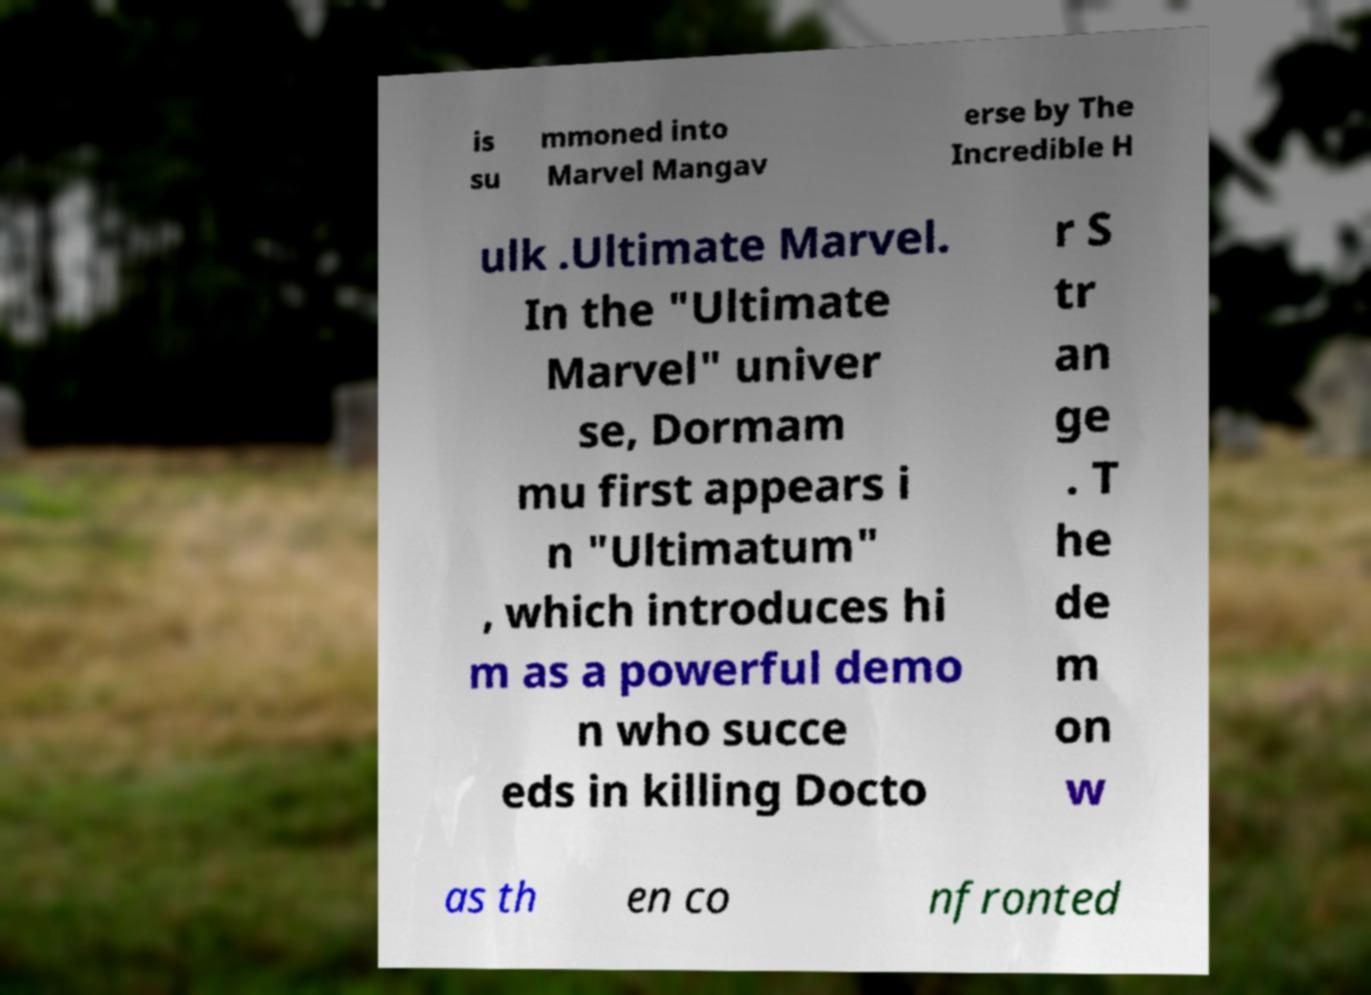Please read and relay the text visible in this image. What does it say? is su mmoned into Marvel Mangav erse by The Incredible H ulk .Ultimate Marvel. In the "Ultimate Marvel" univer se, Dormam mu first appears i n "Ultimatum" , which introduces hi m as a powerful demo n who succe eds in killing Docto r S tr an ge . T he de m on w as th en co nfronted 